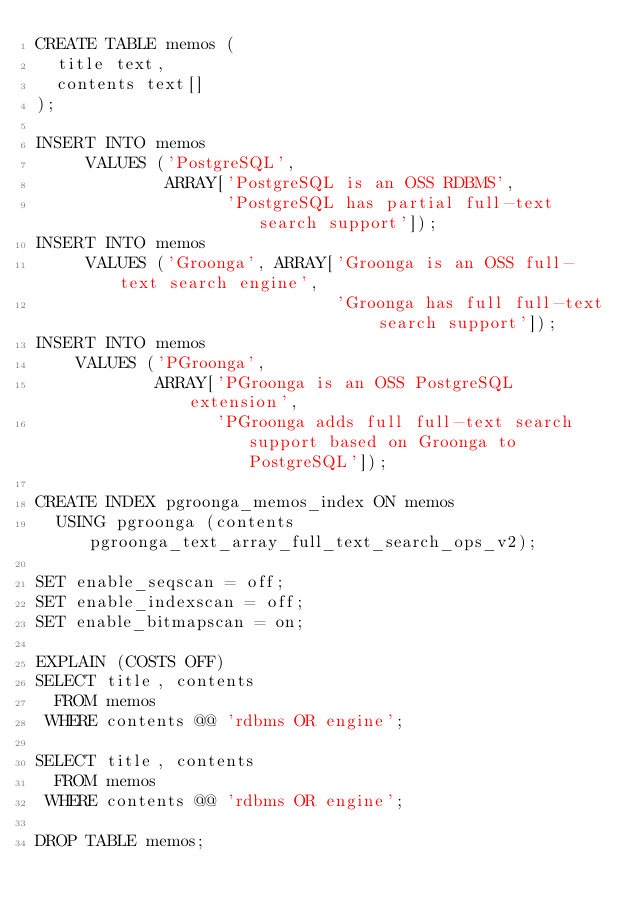<code> <loc_0><loc_0><loc_500><loc_500><_SQL_>CREATE TABLE memos (
  title text,
  contents text[]
);

INSERT INTO memos
     VALUES ('PostgreSQL',
             ARRAY['PostgreSQL is an OSS RDBMS',
                   'PostgreSQL has partial full-text search support']);
INSERT INTO memos
     VALUES ('Groonga', ARRAY['Groonga is an OSS full-text search engine',
                              'Groonga has full full-text search support']);
INSERT INTO memos
    VALUES ('PGroonga',
            ARRAY['PGroonga is an OSS PostgreSQL extension',
                  'PGroonga adds full full-text search support based on Groonga to PostgreSQL']);

CREATE INDEX pgroonga_memos_index ON memos
  USING pgroonga (contents pgroonga_text_array_full_text_search_ops_v2);

SET enable_seqscan = off;
SET enable_indexscan = off;
SET enable_bitmapscan = on;

EXPLAIN (COSTS OFF)
SELECT title, contents
  FROM memos
 WHERE contents @@ 'rdbms OR engine';

SELECT title, contents
  FROM memos
 WHERE contents @@ 'rdbms OR engine';

DROP TABLE memos;
</code> 